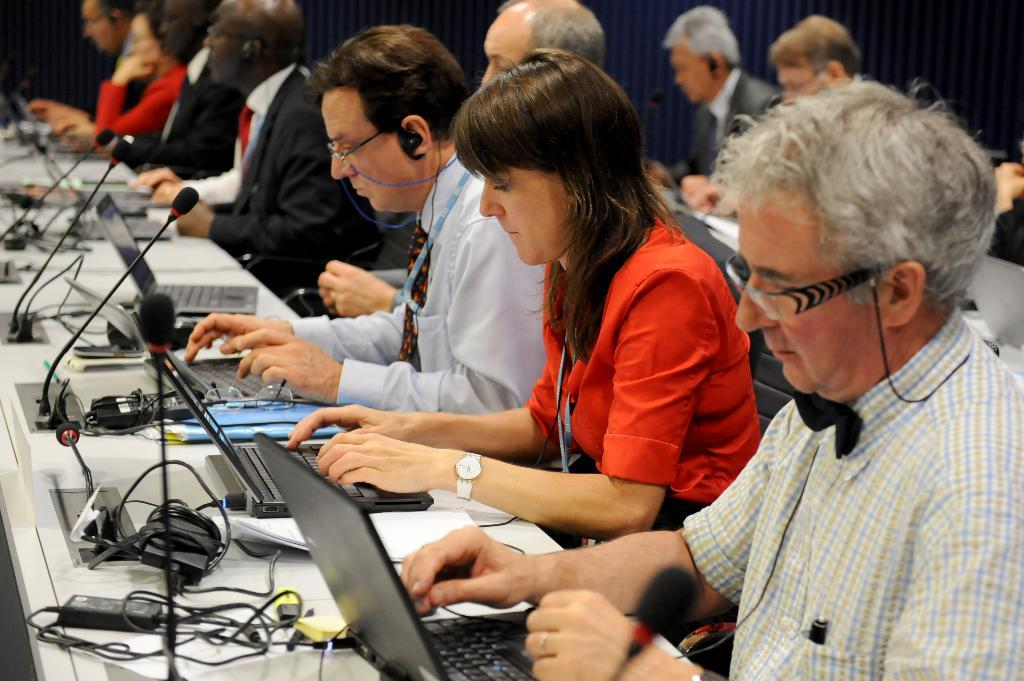What is happening in the image involving the group of people? The people in the image are sitting on chairs and working on laptops. What objects are present in the image to support the people's activities? There are tables in the image, and a microphone arrangement is set up on the tables. What type of surprise is being prepared by the team in the image? There is no indication of a surprise or a team in the image. The people are working on laptops, and there is a microphone arrangement on the tables. 